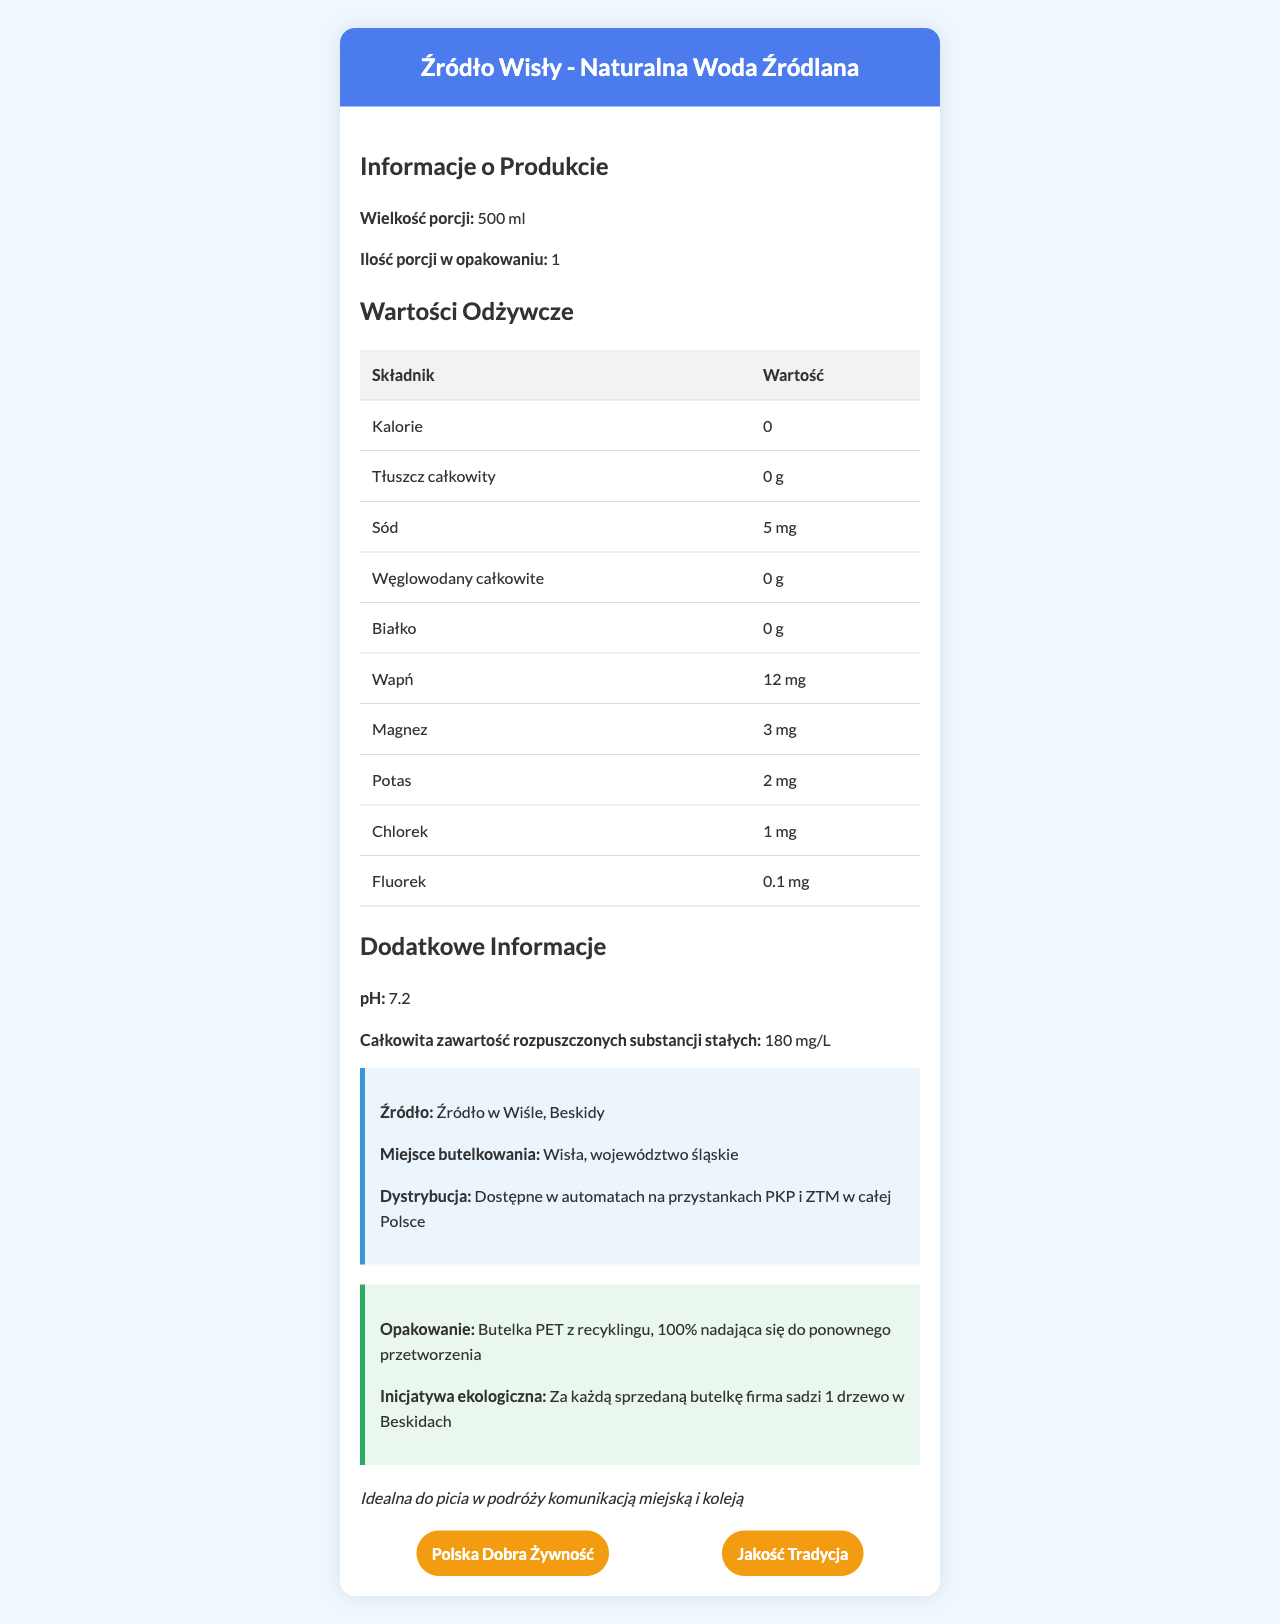What is the brand name of the bottled water? The brand name is mentioned at the top of the document under the header section.
Answer: Źródło Wisły What is the serving size for this bottled water? The serving size is specified as "500 ml" in the "Informacje o Produkcie" section.
Answer: 500 ml How many calories are in a serving of this bottled water? The table under the "Wartości Odżywcze" section shows "Kalorie" as 0.
Answer: 0 Which of the following certifications does this bottled water have? A. Polska Dobra Żywność B. Jakość Tradycja C. EcoCert D. Both A and B The "certifications" section lists "Polska Dobra Żywność" and "Jakość Tradycja," but not "EcoCert."
Answer: D What is the sodium content in a serving of this water? The table under "Wartości Odżywcze" lists "Sód" as 5 mg.
Answer: 5 mg Does this bottled water contain any protein? The "Wartości Odżywcze" table shows "Białko" (protein) as 0 g.
Answer: No Where is this bottled water sourced from? The "Źródło" information under the "Dodatkowe Informacje" section states the source location.
Answer: Źródło w Wiśle, Beskidy What is the pH level of this bottled water? The pH level is listed under the "Dodatkowe Informacje" section.
Answer: 7.2 Summarize the main idea of this document. The document contains comprehensive information about the product, including nutritional values, origin, packaging, certifications, and environmental efforts.
Answer: This document provides nutritional information and various details about the bottled water "Naturalna Woda Źródlana" by the brand "Źródło Wisły." It includes serving size, nutritional content, source, bottling location, and certifications. The document also highlights the eco-friendly initiatives by the brand. What is the total dissolved solids content in this bottled water? The "Dodatkowe Informacje" section lists the total dissolved solids as 180 mg/L.
Answer: 180 mg/L Is the packaging of this bottled water recyclable? The "Opakowanie" section mentions that the bottle is 100% recyclable.
Answer: Yes Which region is this bottled water bottled in? A. Mazowieckie B. Śląskie C. Małopolskie The "Miejsce butelkowania" information states the bottling location as Wisła, województwo śląskie.
Answer: B How much calcium is present in this bottled water? The "Wartości Odżywcze" table lists "Wapń" (calcium) as 12 mg.
Answer: 12 mg What is the company's eco initiative for this bottled water? The "Inicjatywa ekologiczna" section mentions planting one tree for each bottle sold.
Answer: For every bottle sold, the company plants one tree in Beskidy. What is the chloride content in a serving of this water? The table under the "Wartości Odżywcze" lists "Chlorek" as 1 mg.
Answer: 1 mg What types of public transport stops can you find this bottled water? The "Dystrybucja" section mentions availability in vending machines at PKP and ZTM stops.
Answer: PKP and ZTM Does this bottled water have any carbohydrate content? A. Yes B. No The "Wartości Odżywcze" table shows "Węglowodany całkowite" (total carbohydrates) as 0 g.
Answer: B What is the bottling location of this water? The "Miejsce butelkowania" section specifies Wisła in the Śląskie region.
Answer: Wisła, województwo śląskie Which mineral is present in the smallest amount in this bottled water? A. Magnesium B. Potassium C. Chloride D. Fluoride The "Wartości Odżywcze" table lists "Fluorek" (fluoride) as 0.1 mg, which is lower than the amounts of magnesium, potassium, and chloride.
Answer: D What is the annual sales figure for this bottled water brand? There is no information provided about the sales figures in the document.
Answer: Cannot be determined 